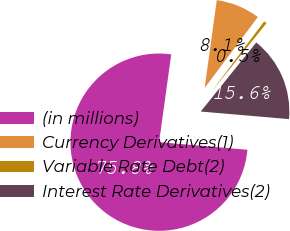Convert chart to OTSL. <chart><loc_0><loc_0><loc_500><loc_500><pie_chart><fcel>(in millions)<fcel>Currency Derivatives(1)<fcel>Variable Rate Debt(2)<fcel>Interest Rate Derivatives(2)<nl><fcel>75.83%<fcel>8.06%<fcel>0.53%<fcel>15.59%<nl></chart> 